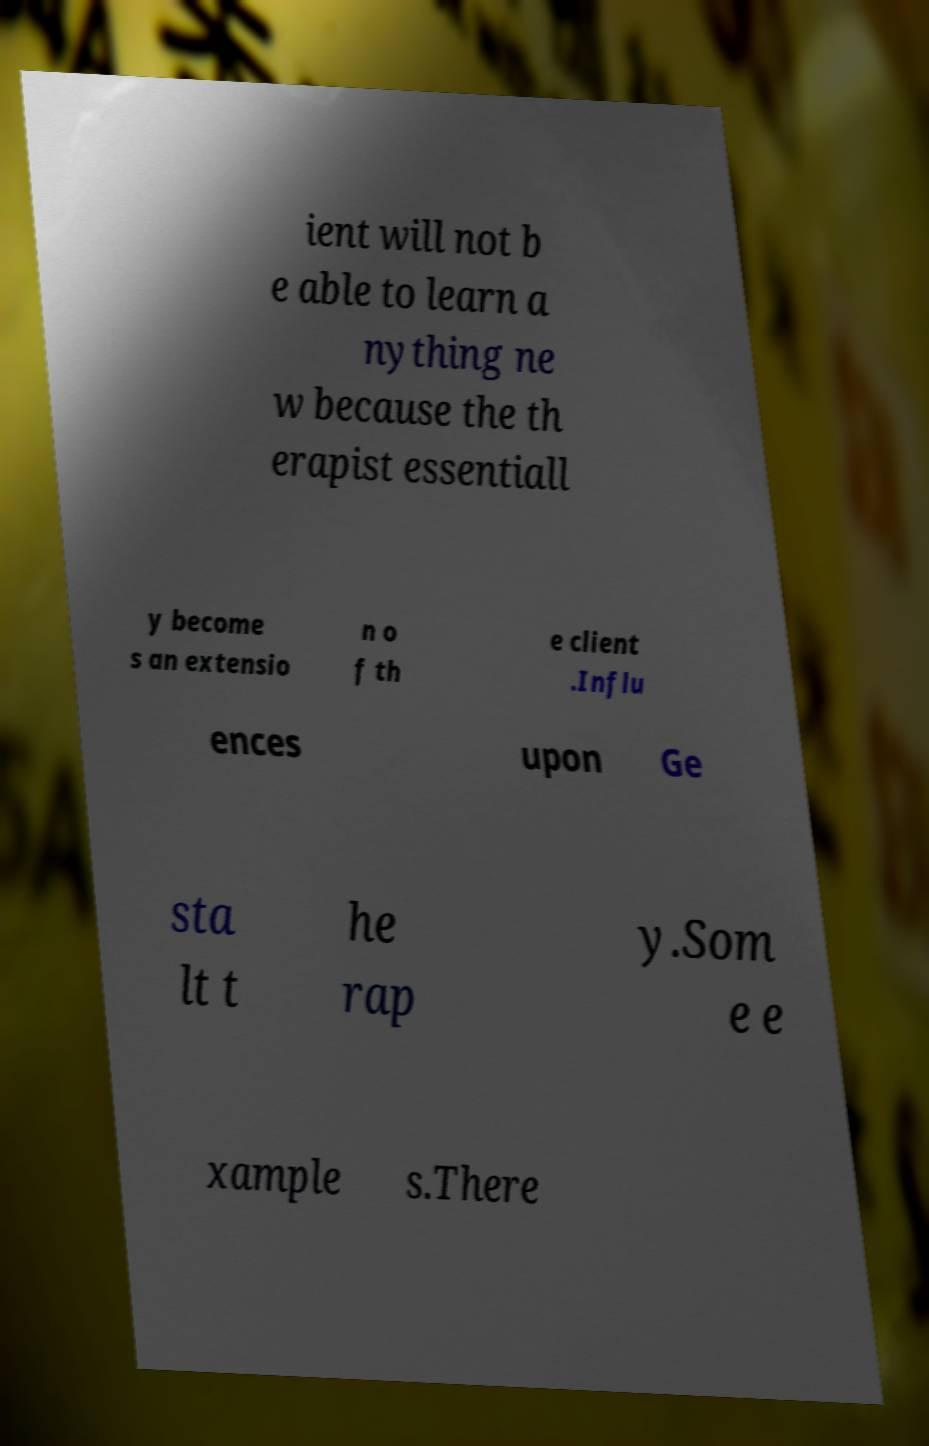Could you extract and type out the text from this image? ient will not b e able to learn a nything ne w because the th erapist essentiall y become s an extensio n o f th e client .Influ ences upon Ge sta lt t he rap y.Som e e xample s.There 